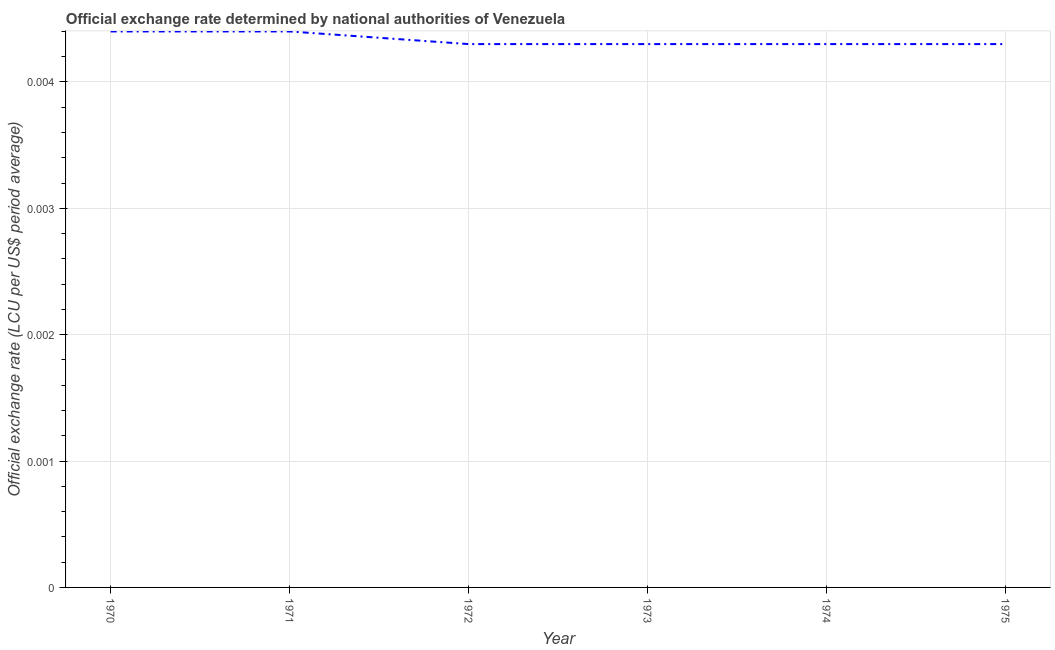What is the official exchange rate in 1975?
Provide a short and direct response. 0. Across all years, what is the maximum official exchange rate?
Offer a terse response. 0. Across all years, what is the minimum official exchange rate?
Provide a short and direct response. 0. In which year was the official exchange rate maximum?
Offer a very short reply. 1970. In which year was the official exchange rate minimum?
Make the answer very short. 1972. What is the sum of the official exchange rate?
Offer a very short reply. 0.03. What is the difference between the official exchange rate in 1971 and 1972?
Ensure brevity in your answer.  0. What is the average official exchange rate per year?
Your answer should be compact. 0. What is the median official exchange rate?
Offer a very short reply. 0. In how many years, is the official exchange rate greater than 0.003 ?
Make the answer very short. 6. Do a majority of the years between 1972 and 1970 (inclusive) have official exchange rate greater than 0.004 ?
Keep it short and to the point. No. What is the ratio of the official exchange rate in 1973 to that in 1974?
Your answer should be very brief. 1. Is the difference between the official exchange rate in 1972 and 1975 greater than the difference between any two years?
Keep it short and to the point. No. What is the difference between the highest and the lowest official exchange rate?
Your answer should be very brief. 0. In how many years, is the official exchange rate greater than the average official exchange rate taken over all years?
Offer a terse response. 2. How many years are there in the graph?
Give a very brief answer. 6. What is the difference between two consecutive major ticks on the Y-axis?
Provide a succinct answer. 0. What is the title of the graph?
Your answer should be compact. Official exchange rate determined by national authorities of Venezuela. What is the label or title of the X-axis?
Keep it short and to the point. Year. What is the label or title of the Y-axis?
Make the answer very short. Official exchange rate (LCU per US$ period average). What is the Official exchange rate (LCU per US$ period average) of 1970?
Offer a very short reply. 0. What is the Official exchange rate (LCU per US$ period average) in 1971?
Give a very brief answer. 0. What is the Official exchange rate (LCU per US$ period average) in 1972?
Your response must be concise. 0. What is the Official exchange rate (LCU per US$ period average) in 1973?
Offer a terse response. 0. What is the Official exchange rate (LCU per US$ period average) in 1974?
Your response must be concise. 0. What is the Official exchange rate (LCU per US$ period average) in 1975?
Ensure brevity in your answer.  0. What is the difference between the Official exchange rate (LCU per US$ period average) in 1970 and 1972?
Provide a short and direct response. 0. What is the difference between the Official exchange rate (LCU per US$ period average) in 1970 and 1973?
Provide a succinct answer. 0. What is the difference between the Official exchange rate (LCU per US$ period average) in 1971 and 1973?
Offer a very short reply. 0. What is the difference between the Official exchange rate (LCU per US$ period average) in 1971 and 1975?
Give a very brief answer. 0. What is the difference between the Official exchange rate (LCU per US$ period average) in 1972 and 1973?
Make the answer very short. 0. What is the difference between the Official exchange rate (LCU per US$ period average) in 1972 and 1974?
Provide a succinct answer. 0. What is the difference between the Official exchange rate (LCU per US$ period average) in 1973 and 1974?
Give a very brief answer. 0. What is the ratio of the Official exchange rate (LCU per US$ period average) in 1970 to that in 1971?
Provide a short and direct response. 1. What is the ratio of the Official exchange rate (LCU per US$ period average) in 1970 to that in 1972?
Your answer should be compact. 1.02. What is the ratio of the Official exchange rate (LCU per US$ period average) in 1971 to that in 1974?
Keep it short and to the point. 1.02. What is the ratio of the Official exchange rate (LCU per US$ period average) in 1971 to that in 1975?
Your response must be concise. 1.02. What is the ratio of the Official exchange rate (LCU per US$ period average) in 1972 to that in 1974?
Provide a succinct answer. 1. What is the ratio of the Official exchange rate (LCU per US$ period average) in 1973 to that in 1975?
Your response must be concise. 1. 